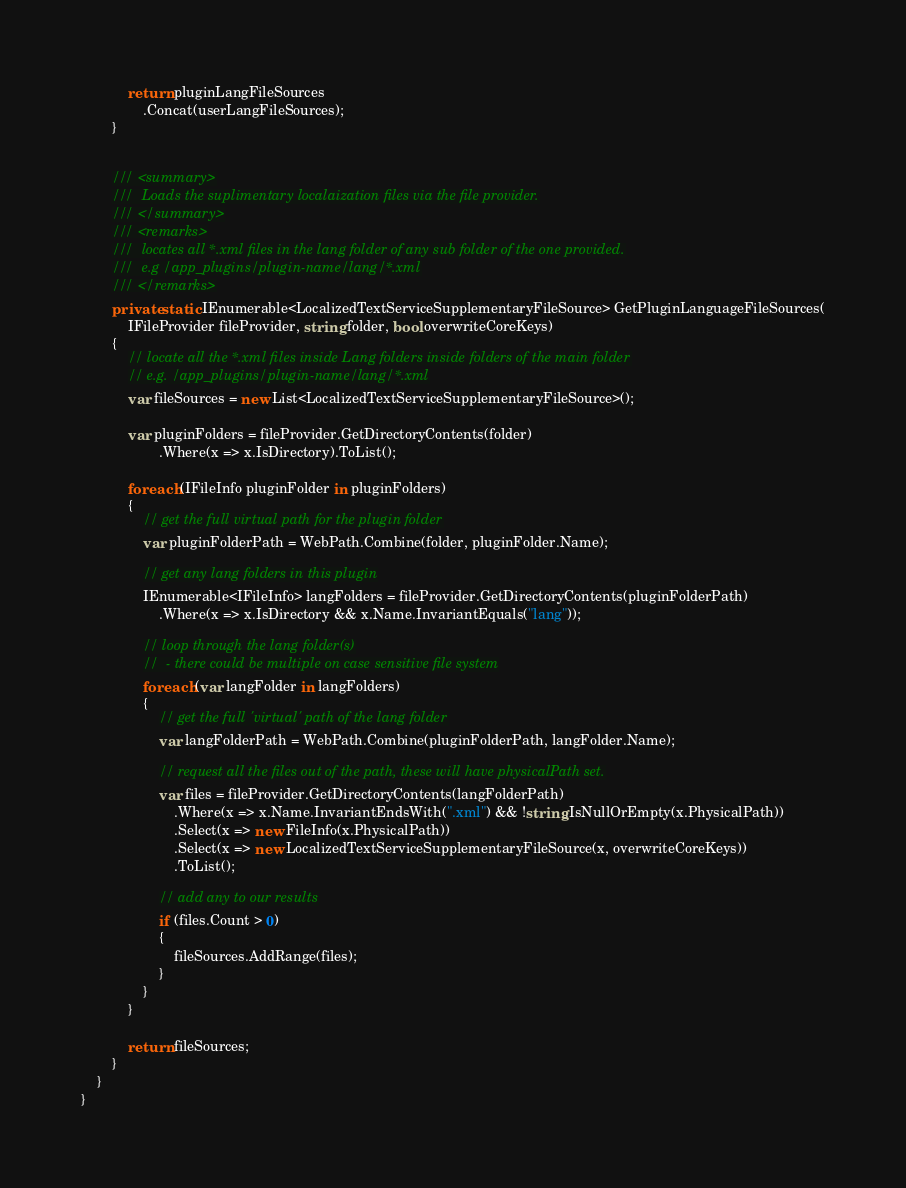<code> <loc_0><loc_0><loc_500><loc_500><_C#_>            return pluginLangFileSources
                .Concat(userLangFileSources);
        }


        /// <summary>
        ///  Loads the suplimentary localaization files via the file provider.
        /// </summary>
        /// <remarks>
        ///  locates all *.xml files in the lang folder of any sub folder of the one provided.
        ///  e.g /app_plugins/plugin-name/lang/*.xml
        /// </remarks>
        private static IEnumerable<LocalizedTextServiceSupplementaryFileSource> GetPluginLanguageFileSources(
            IFileProvider fileProvider, string folder, bool overwriteCoreKeys)
        {
            // locate all the *.xml files inside Lang folders inside folders of the main folder
            // e.g. /app_plugins/plugin-name/lang/*.xml
            var fileSources = new List<LocalizedTextServiceSupplementaryFileSource>();

            var pluginFolders = fileProvider.GetDirectoryContents(folder)
                    .Where(x => x.IsDirectory).ToList();

            foreach (IFileInfo pluginFolder in pluginFolders)
            {
                // get the full virtual path for the plugin folder
                var pluginFolderPath = WebPath.Combine(folder, pluginFolder.Name);

                // get any lang folders in this plugin
                IEnumerable<IFileInfo> langFolders = fileProvider.GetDirectoryContents(pluginFolderPath)
                    .Where(x => x.IsDirectory && x.Name.InvariantEquals("lang"));

                // loop through the lang folder(s)
                //  - there could be multiple on case sensitive file system
                foreach (var langFolder in langFolders)
                {
                    // get the full 'virtual' path of the lang folder
                    var langFolderPath = WebPath.Combine(pluginFolderPath, langFolder.Name);

                    // request all the files out of the path, these will have physicalPath set.
                    var files = fileProvider.GetDirectoryContents(langFolderPath)
                        .Where(x => x.Name.InvariantEndsWith(".xml") && !string.IsNullOrEmpty(x.PhysicalPath))
                        .Select(x => new FileInfo(x.PhysicalPath))
                        .Select(x => new LocalizedTextServiceSupplementaryFileSource(x, overwriteCoreKeys))
                        .ToList();

                    // add any to our results
                    if (files.Count > 0)
                    {
                        fileSources.AddRange(files);
                    }
                }
            }

            return fileSources;
        }
    }
}
</code> 